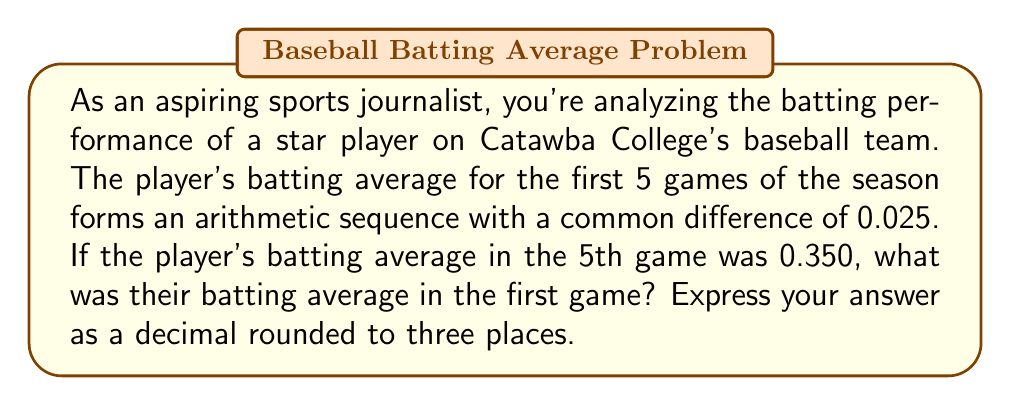Give your solution to this math problem. Let's approach this step-by-step:

1) In an arithmetic sequence, each term differs from the previous term by a constant amount (the common difference).

2) Let's define $a_n$ as the batting average in the $n$th game.

3) We're given that:
   - The common difference, $d = 0.025$
   - $a_5 = 0.350$ (the batting average in the 5th game)

4) In an arithmetic sequence, we can express any term using the first term and the common difference:

   $a_n = a_1 + (n-1)d$

5) For the 5th game:

   $a_5 = a_1 + (5-1)d$
   $0.350 = a_1 + 4(0.025)$

6) Simplify:

   $0.350 = a_1 + 0.100$

7) Solve for $a_1$:

   $a_1 = 0.350 - 0.100 = 0.250$

Therefore, the player's batting average in the first game was 0.250.
Answer: 0.250 